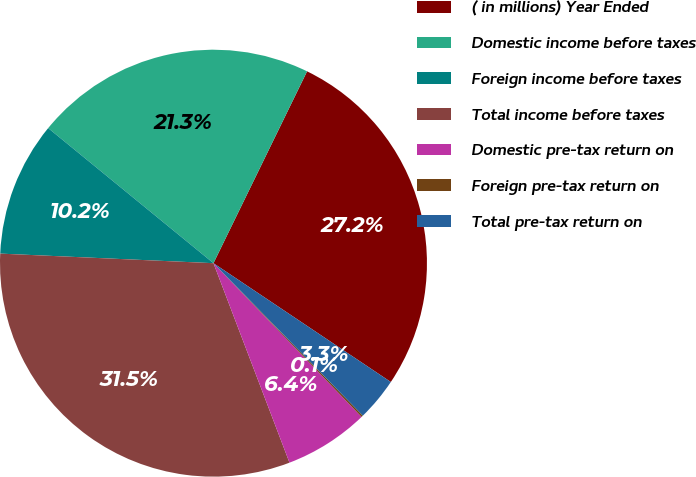Convert chart. <chart><loc_0><loc_0><loc_500><loc_500><pie_chart><fcel>( in millions) Year Ended<fcel>Domestic income before taxes<fcel>Foreign income before taxes<fcel>Total income before taxes<fcel>Domestic pre-tax return on<fcel>Foreign pre-tax return on<fcel>Total pre-tax return on<nl><fcel>27.17%<fcel>21.32%<fcel>10.19%<fcel>31.51%<fcel>6.41%<fcel>0.13%<fcel>3.27%<nl></chart> 